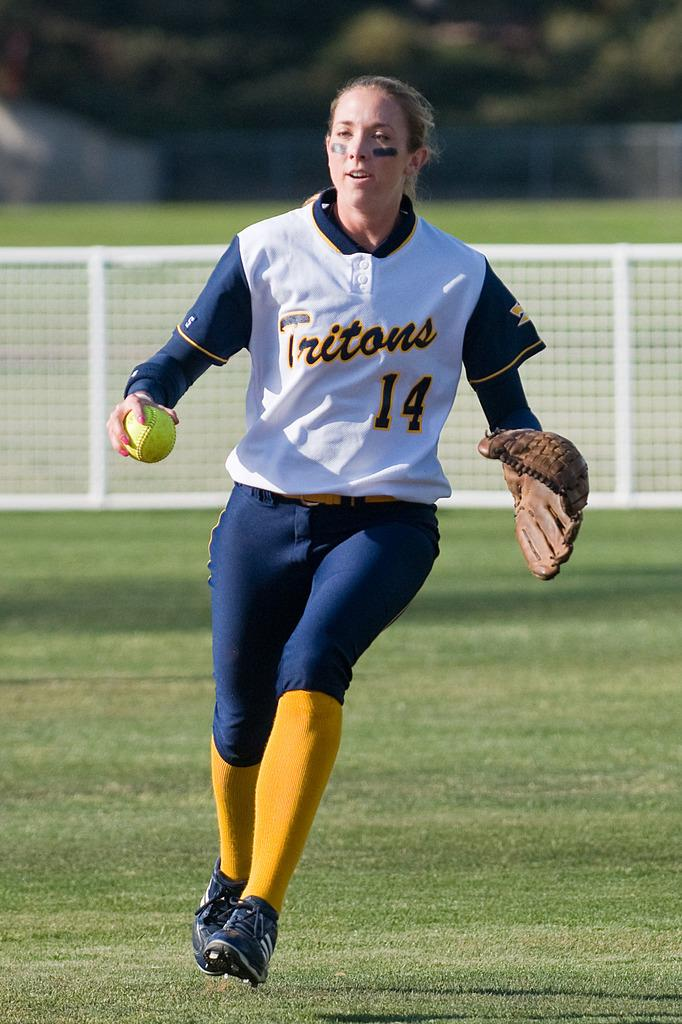Provide a one-sentence caption for the provided image. A woman wearing a Tritons jersey with the number 14 is holding onto a softball. 